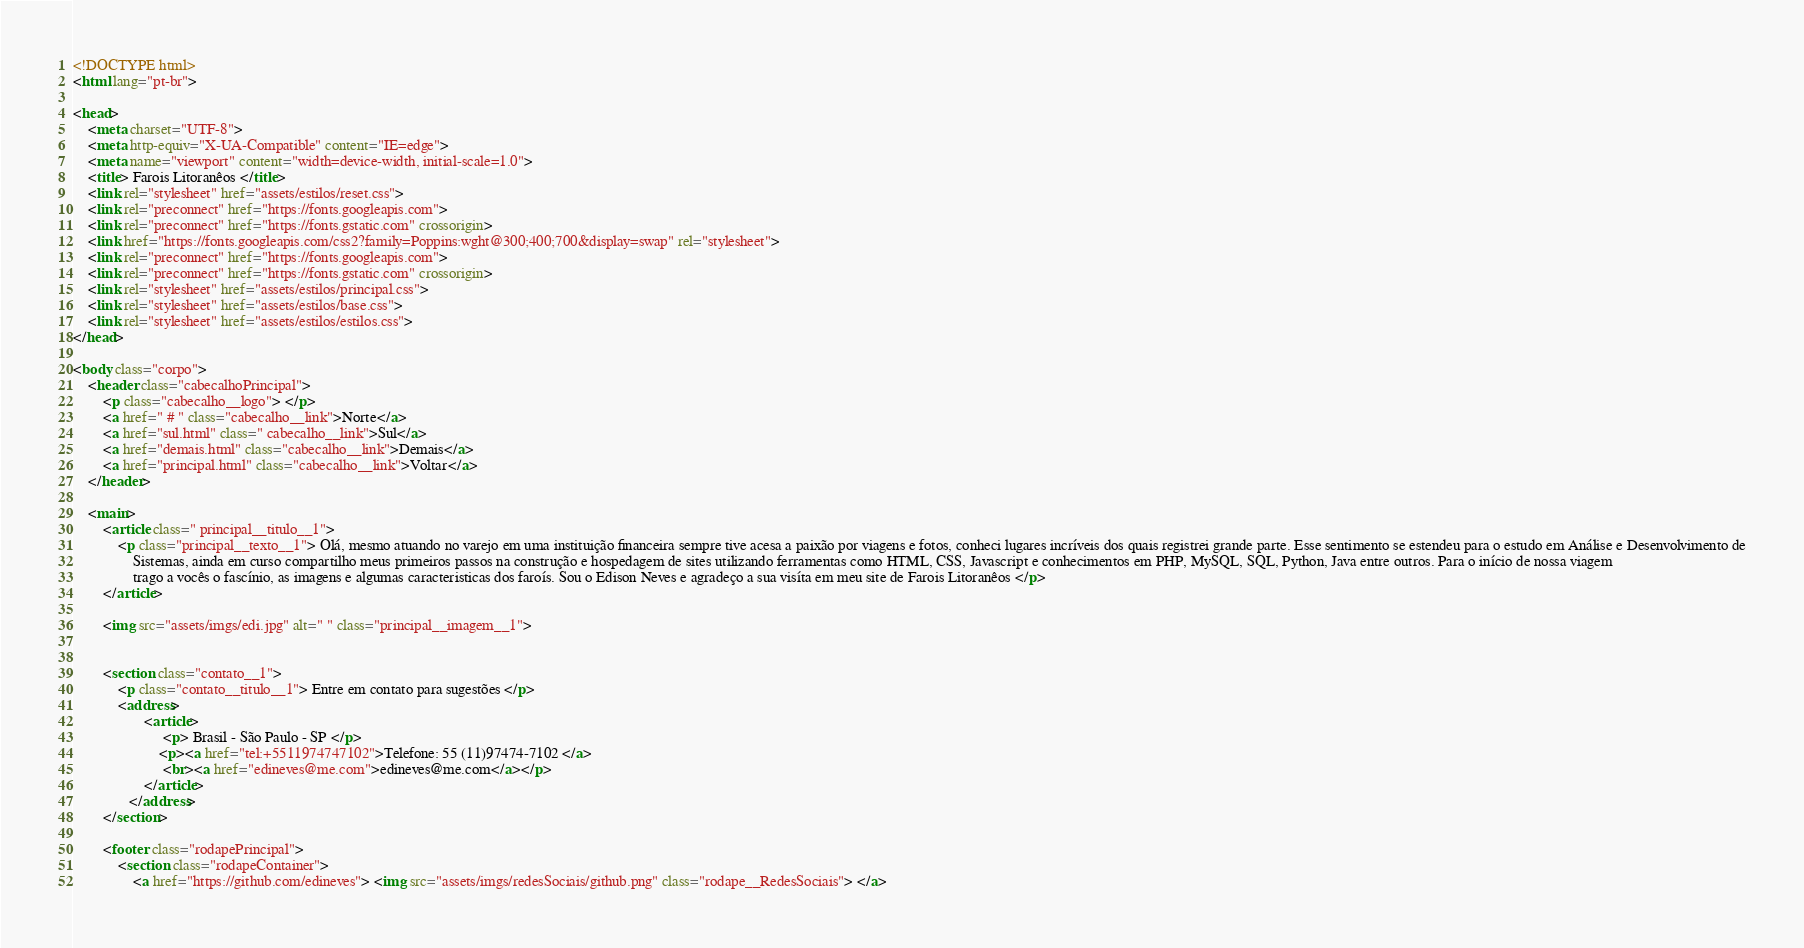Convert code to text. <code><loc_0><loc_0><loc_500><loc_500><_HTML_><!DOCTYPE html>
<html lang="pt-br">

<head>
    <meta charset="UTF-8">
    <meta http-equiv="X-UA-Compatible" content="IE=edge">
    <meta name="viewport" content="width=device-width, initial-scale=1.0">
    <title> Farois Litoranêos </title>
    <link rel="stylesheet" href="assets/estilos/reset.css">
    <link rel="preconnect" href="https://fonts.googleapis.com">
    <link rel="preconnect" href="https://fonts.gstatic.com" crossorigin>
    <link href="https://fonts.googleapis.com/css2?family=Poppins:wght@300;400;700&display=swap" rel="stylesheet">
    <link rel="preconnect" href="https://fonts.googleapis.com">
    <link rel="preconnect" href="https://fonts.gstatic.com" crossorigin>
    <link rel="stylesheet" href="assets/estilos/principal.css">
    <link rel="stylesheet" href="assets/estilos/base.css">
    <link rel="stylesheet" href="assets/estilos/estilos.css">
</head>

<body class="corpo">
    <header class="cabecalhoPrincipal">
        <p class="cabecalho__logo"> </p>
        <a href=" # " class="cabecalho__link">Norte</a>
        <a href="sul.html" class=" cabecalho__link">Sul</a>
        <a href="demais.html" class="cabecalho__link">Demais</a>
        <a href="principal.html" class="cabecalho__link">Voltar</a>
    </header>

    <main>
        <article class=" principal__titulo__1">
            <p class="principal__texto__1"> Olá, mesmo atuando no varejo em uma instituição financeira sempre tive acesa a paixão por viagens e fotos, conheci lugares incríveis dos quais registrei grande parte. Esse sentimento se estendeu para o estudo em Análise e Desenvolvimento de
                Sistemas, ainda em curso compartilho meus primeiros passos na construção e hospedagem de sites utilizando ferramentas como HTML, CSS, Javascript e conhecimentos em PHP, MySQL, SQL, Python, Java entre outros. Para o início de nossa viagem
                trago a vocês o fascínio, as imagens e algumas caracteristicas dos faroís. Sou o Edison Neves e agradeço a sua visíta em meu site de Farois Litoranêos </p>
        </article>

        <img src="assets/imgs/edi.jpg" alt=" " class="principal__imagem__1">


        <section class="contato__1">
            <p class="contato__titulo__1"> Entre em contato para sugestões </p>
            <address>                   
                   <article>
                        <p> Brasil - São Paulo - SP </p>
                       <p><a href="tel:+5511974747102">Telefone: 55 (11)97474-7102 </a>
                        <br><a href="edineves@me.com">edineves@me.com</a></p>
                   </article>                  
               </address>
        </section>

        <footer class="rodapePrincipal">
            <section class="rodapeContainer">
                <a href="https://github.com/edineves"> <img src="assets/imgs/redesSociais/github.png" class="rodape__RedesSociais"> </a></code> 